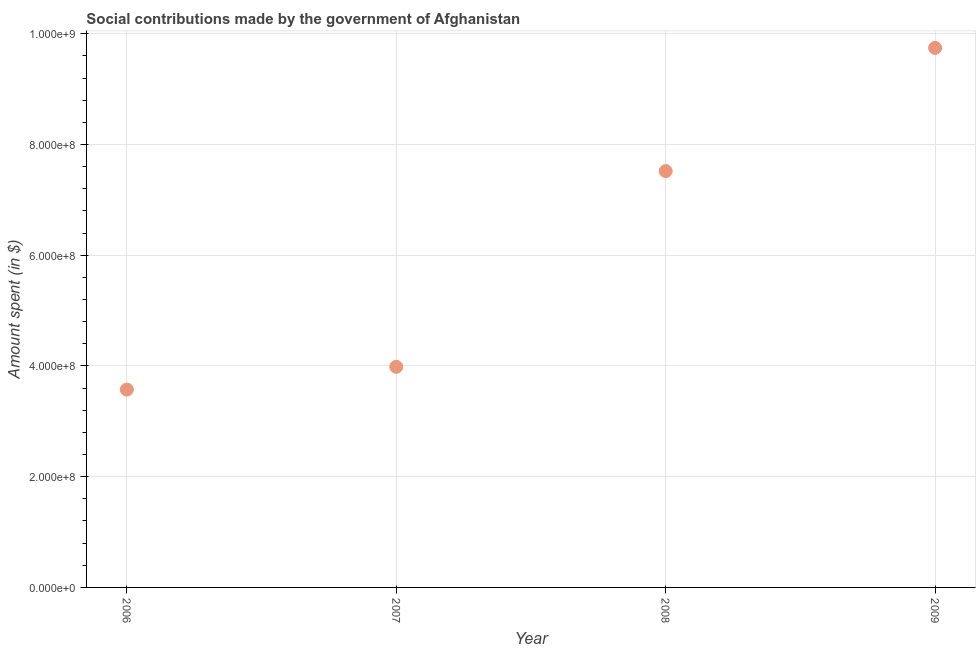What is the amount spent in making social contributions in 2009?
Keep it short and to the point. 9.74e+08. Across all years, what is the maximum amount spent in making social contributions?
Provide a succinct answer. 9.74e+08. Across all years, what is the minimum amount spent in making social contributions?
Provide a short and direct response. 3.57e+08. In which year was the amount spent in making social contributions minimum?
Offer a terse response. 2006. What is the sum of the amount spent in making social contributions?
Your answer should be compact. 2.48e+09. What is the difference between the amount spent in making social contributions in 2008 and 2009?
Your answer should be very brief. -2.22e+08. What is the average amount spent in making social contributions per year?
Provide a short and direct response. 6.21e+08. What is the median amount spent in making social contributions?
Ensure brevity in your answer.  5.75e+08. What is the ratio of the amount spent in making social contributions in 2006 to that in 2009?
Keep it short and to the point. 0.37. Is the difference between the amount spent in making social contributions in 2007 and 2009 greater than the difference between any two years?
Your response must be concise. No. What is the difference between the highest and the second highest amount spent in making social contributions?
Offer a very short reply. 2.22e+08. What is the difference between the highest and the lowest amount spent in making social contributions?
Your answer should be very brief. 6.17e+08. In how many years, is the amount spent in making social contributions greater than the average amount spent in making social contributions taken over all years?
Offer a very short reply. 2. Does the amount spent in making social contributions monotonically increase over the years?
Provide a succinct answer. Yes. How many dotlines are there?
Ensure brevity in your answer.  1. Does the graph contain grids?
Offer a very short reply. Yes. What is the title of the graph?
Your answer should be compact. Social contributions made by the government of Afghanistan. What is the label or title of the X-axis?
Provide a short and direct response. Year. What is the label or title of the Y-axis?
Your answer should be compact. Amount spent (in $). What is the Amount spent (in $) in 2006?
Offer a terse response. 3.57e+08. What is the Amount spent (in $) in 2007?
Provide a short and direct response. 3.98e+08. What is the Amount spent (in $) in 2008?
Offer a very short reply. 7.52e+08. What is the Amount spent (in $) in 2009?
Your response must be concise. 9.74e+08. What is the difference between the Amount spent (in $) in 2006 and 2007?
Keep it short and to the point. -4.11e+07. What is the difference between the Amount spent (in $) in 2006 and 2008?
Ensure brevity in your answer.  -3.95e+08. What is the difference between the Amount spent (in $) in 2006 and 2009?
Your answer should be very brief. -6.17e+08. What is the difference between the Amount spent (in $) in 2007 and 2008?
Offer a very short reply. -3.54e+08. What is the difference between the Amount spent (in $) in 2007 and 2009?
Provide a succinct answer. -5.76e+08. What is the difference between the Amount spent (in $) in 2008 and 2009?
Offer a very short reply. -2.22e+08. What is the ratio of the Amount spent (in $) in 2006 to that in 2007?
Give a very brief answer. 0.9. What is the ratio of the Amount spent (in $) in 2006 to that in 2008?
Give a very brief answer. 0.47. What is the ratio of the Amount spent (in $) in 2006 to that in 2009?
Offer a terse response. 0.37. What is the ratio of the Amount spent (in $) in 2007 to that in 2008?
Provide a short and direct response. 0.53. What is the ratio of the Amount spent (in $) in 2007 to that in 2009?
Give a very brief answer. 0.41. What is the ratio of the Amount spent (in $) in 2008 to that in 2009?
Make the answer very short. 0.77. 